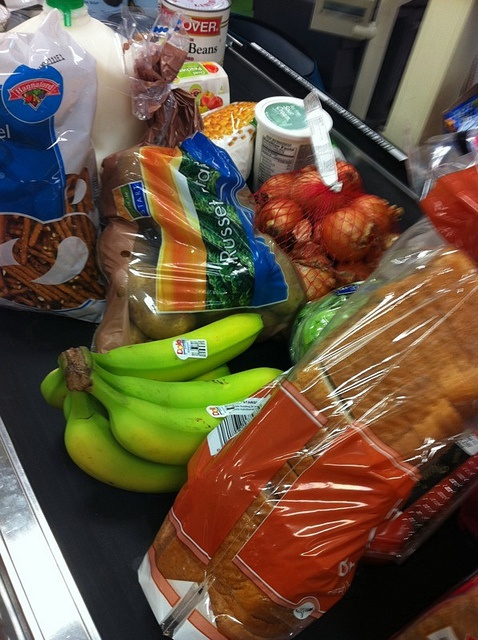Describe the objects in this image and their specific colors. I can see banana in black, green, darkgreen, and khaki tones, banana in black and olive tones, banana in black, olive, and darkgreen tones, and banana in black, olive, lime, and darkgreen tones in this image. 